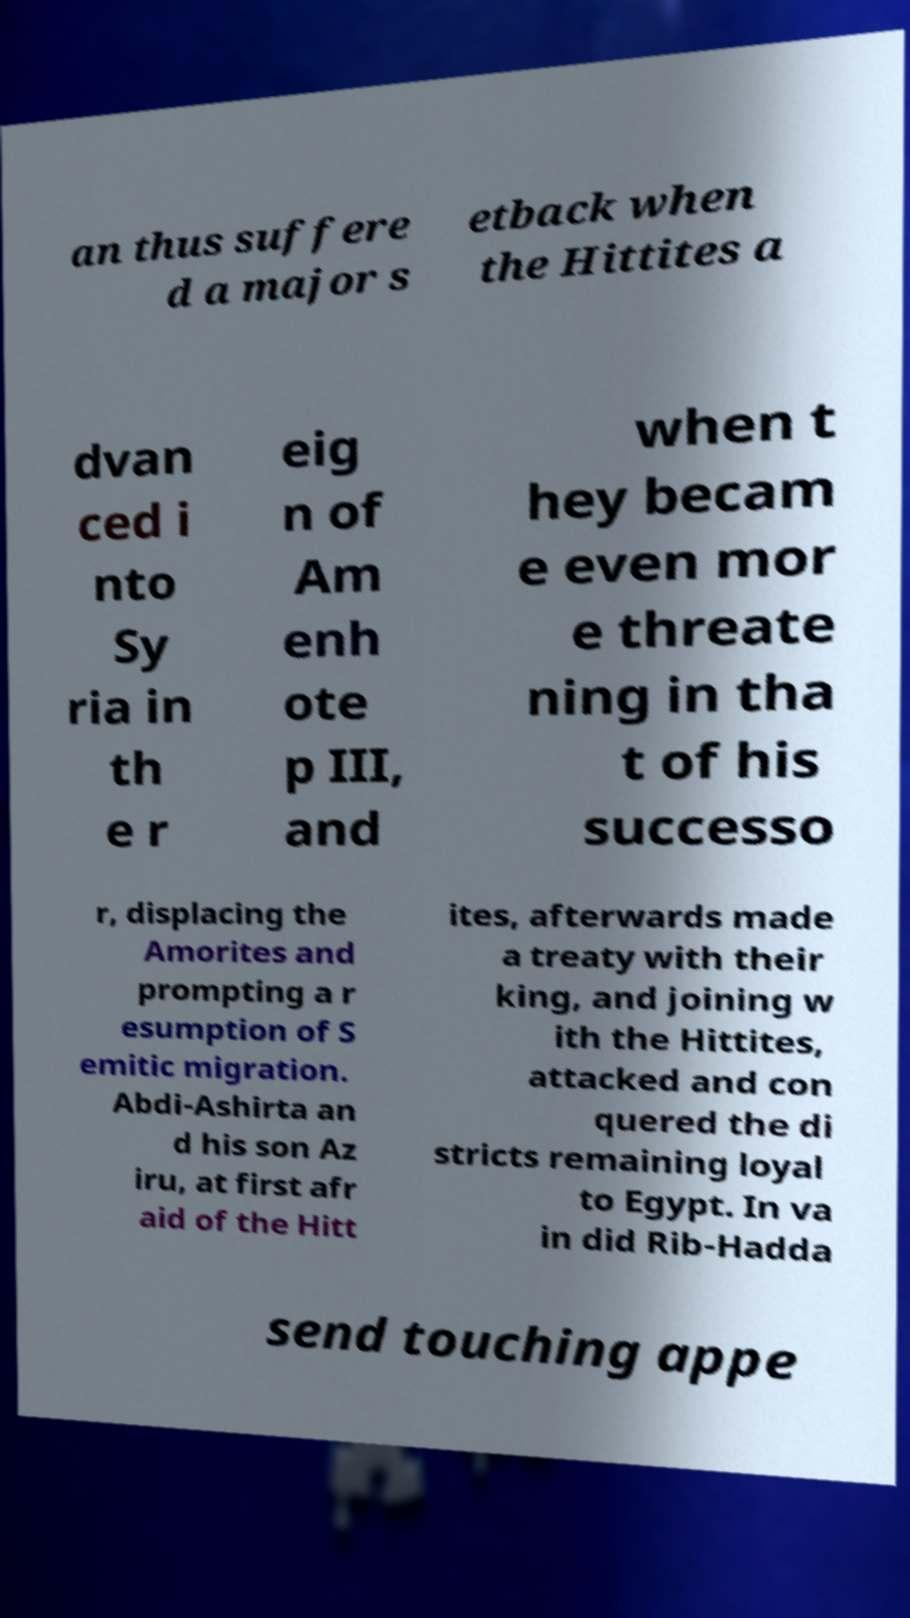Please identify and transcribe the text found in this image. an thus suffere d a major s etback when the Hittites a dvan ced i nto Sy ria in th e r eig n of Am enh ote p III, and when t hey becam e even mor e threate ning in tha t of his successo r, displacing the Amorites and prompting a r esumption of S emitic migration. Abdi-Ashirta an d his son Az iru, at first afr aid of the Hitt ites, afterwards made a treaty with their king, and joining w ith the Hittites, attacked and con quered the di stricts remaining loyal to Egypt. In va in did Rib-Hadda send touching appe 